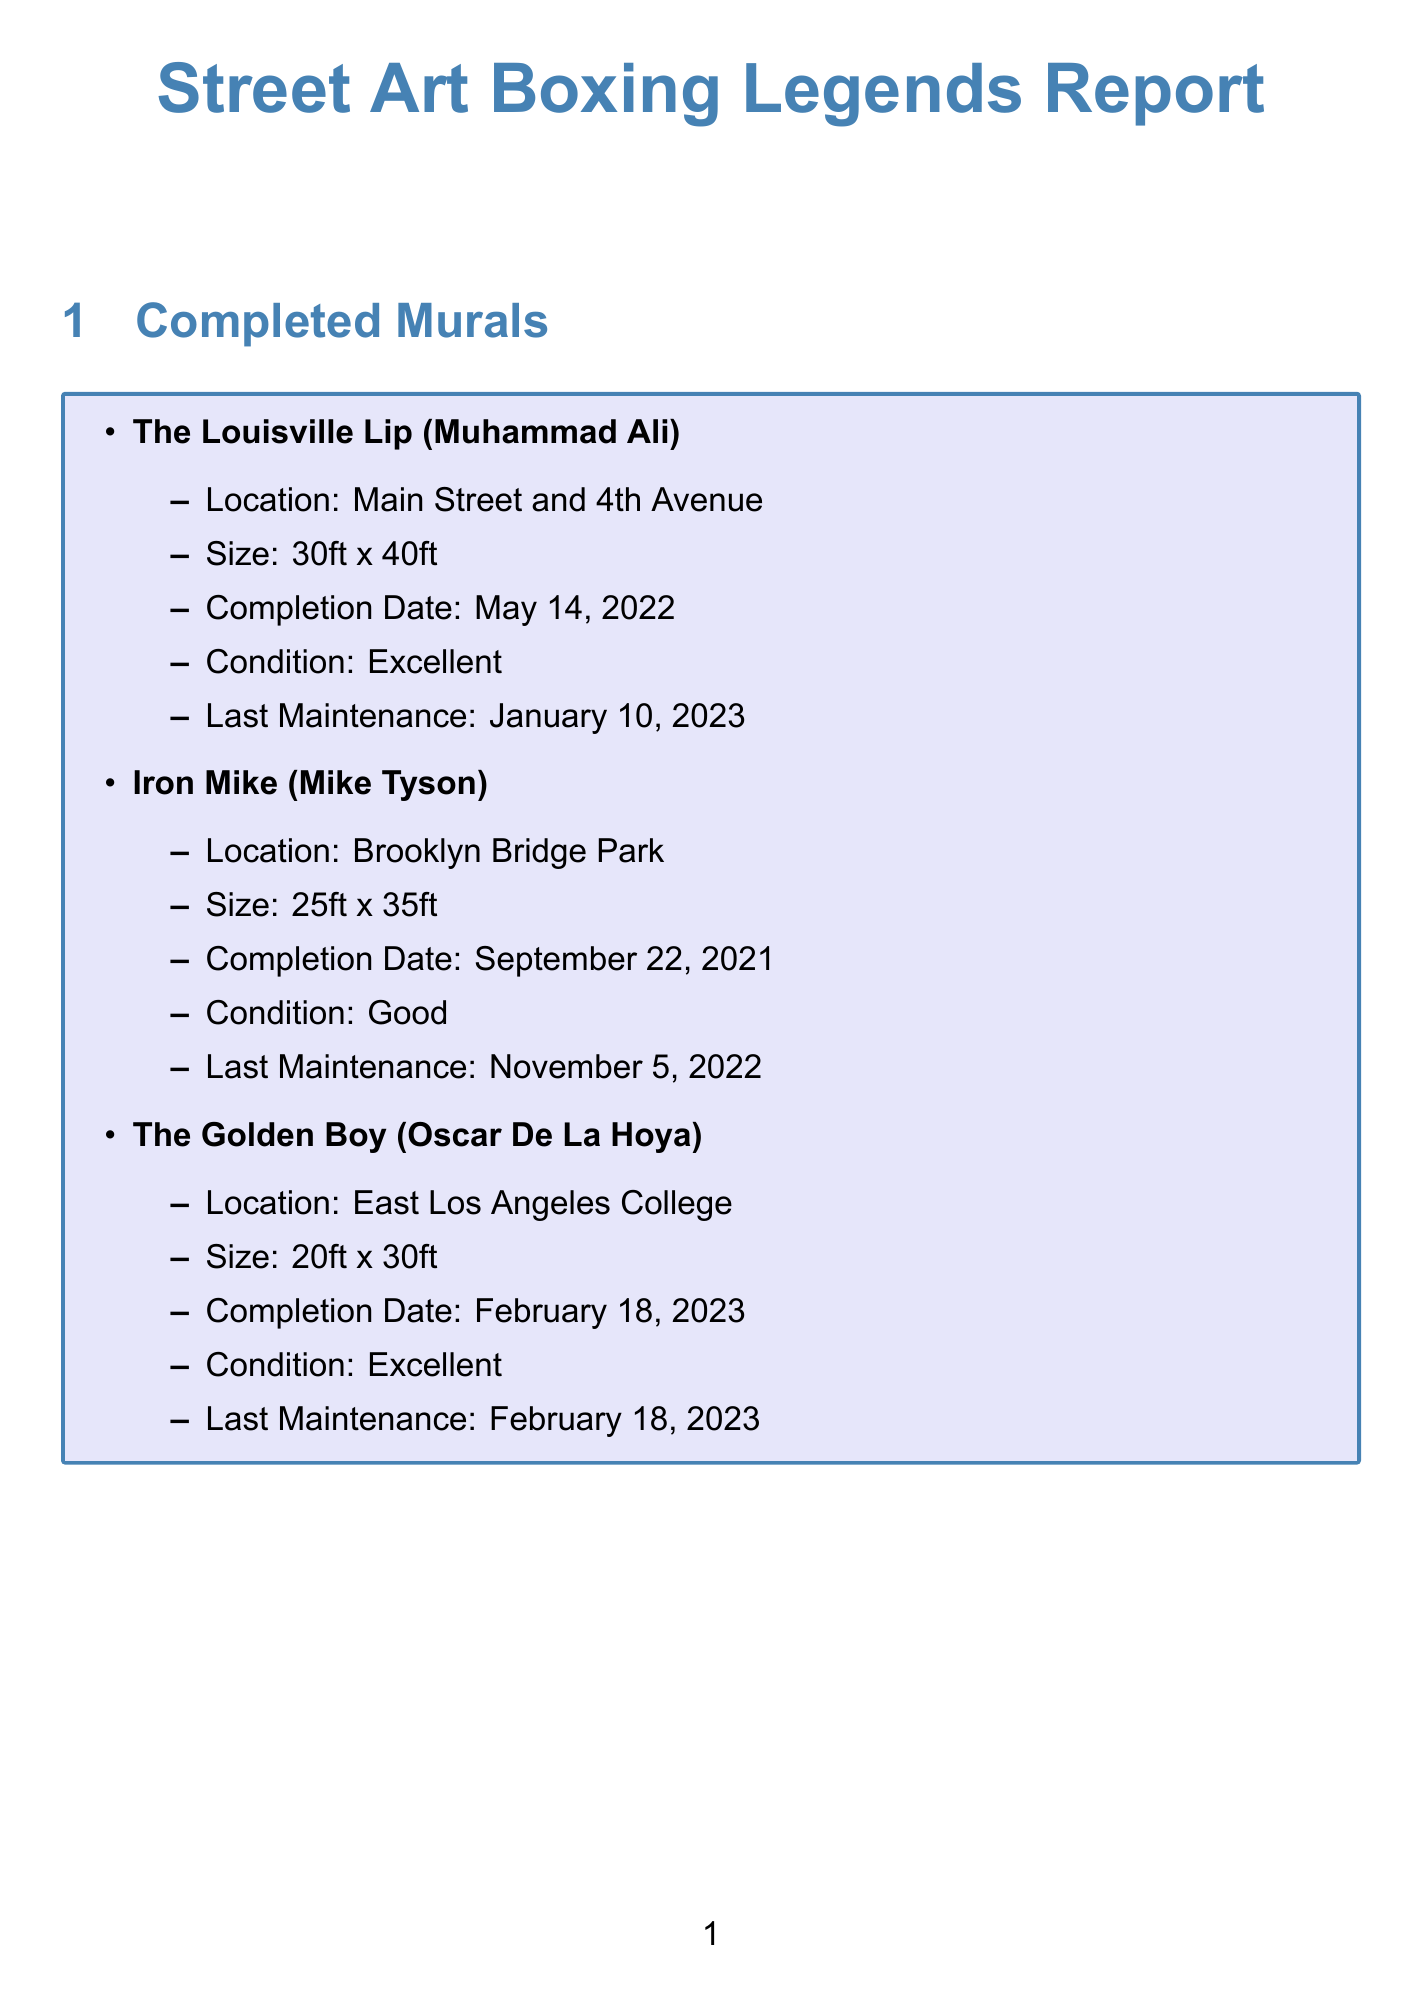What is the title of the mural depicting Muhammad Ali? The title of the mural depicting Muhammad Ali is "The Louisville Lip."
Answer: The Louisville Lip When was "Iron Mike" completed? "Iron Mike" was completed on September 22, 2021.
Answer: September 22, 2021 What is the condition of "The Golden Boy"? The condition of "The Golden Boy" is Excellent.
Answer: Excellent How many gallons of exterior acrylic paint are available? There are 50 gallons of exterior acrylic paint available.
Answer: 50 gallons What maintenance task is scheduled for "The Louisville Lip" on October 1, 2023? The maintenance task scheduled for "The Louisville Lip" on October 1, 2023, is Touch-up.
Answer: Touch-up Which mural is located at Brooklyn Bridge Park? The mural located at Brooklyn Bridge Park is "Iron Mike."
Answer: Iron Mike What event is scheduled for July 22, 2023? The event scheduled for July 22, 2023, is the Boxing History Workshop.
Answer: Boxing History Workshop What is the estimated duration for the project "Hands of Stone"? The estimated duration for the project "Hands of Stone" is 5 weeks.
Answer: 5 weeks What is the location for "The Manassa Mauler"? The location for "The Manassa Mauler" is Denver Union Station.
Answer: Denver Union Station 